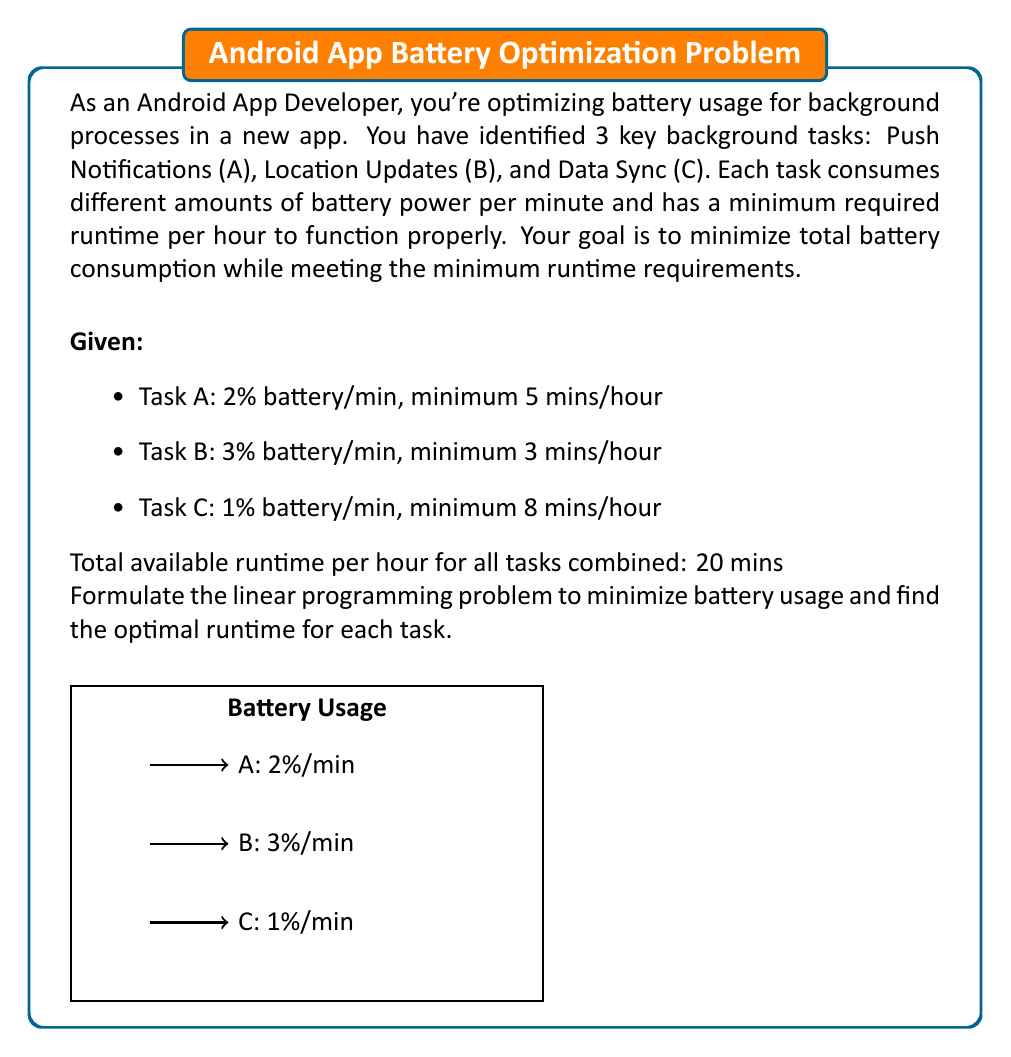Solve this math problem. Let's approach this step-by-step:

1) Define variables:
   Let $x_A$, $x_B$, and $x_C$ be the number of minutes allocated to tasks A, B, and C respectively.

2) Objective function:
   We want to minimize the total battery usage. The objective function is:
   Minimize: $Z = 2x_A + 3x_B + x_C$

3) Constraints:
   a) Minimum runtime for each task:
      $x_A \geq 5$
      $x_B \geq 3$
      $x_C \geq 8$

   b) Total available runtime:
      $x_A + x_B + x_C \leq 20$

   c) Non-negativity:
      $x_A, x_B, x_C \geq 0$

4) Complete linear programming formulation:

   Minimize: $Z = 2x_A + 3x_B + x_C$

   Subject to:
   $x_A \geq 5$
   $x_B \geq 3$
   $x_C \geq 8$
   $x_A + x_B + x_C \leq 20$
   $x_A, x_B, x_C \geq 0$

5) Solving the LP problem:
   The optimal solution can be found using the simplex method or linear programming software. However, we can deduce the solution logically:

   - Task B has the highest battery consumption per minute, so we should allocate the minimum required time (3 mins).
   - Task A has the second-highest consumption, so we allocate its minimum (5 mins).
   - Task C has the lowest consumption, so we can allocate the remaining time (12 mins).

6) Optimal solution:
   $x_A = 5$ mins
   $x_B = 3$ mins
   $x_C = 12$ mins

7) Minimum battery usage:
   $Z = 2(5) + 3(3) + 1(12) = 10 + 9 + 12 = 31$ % battery

This solution minimizes battery usage while meeting all constraints.
Answer: $x_A = 5, x_B = 3, x_C = 12$; Minimum battery usage: 31% 